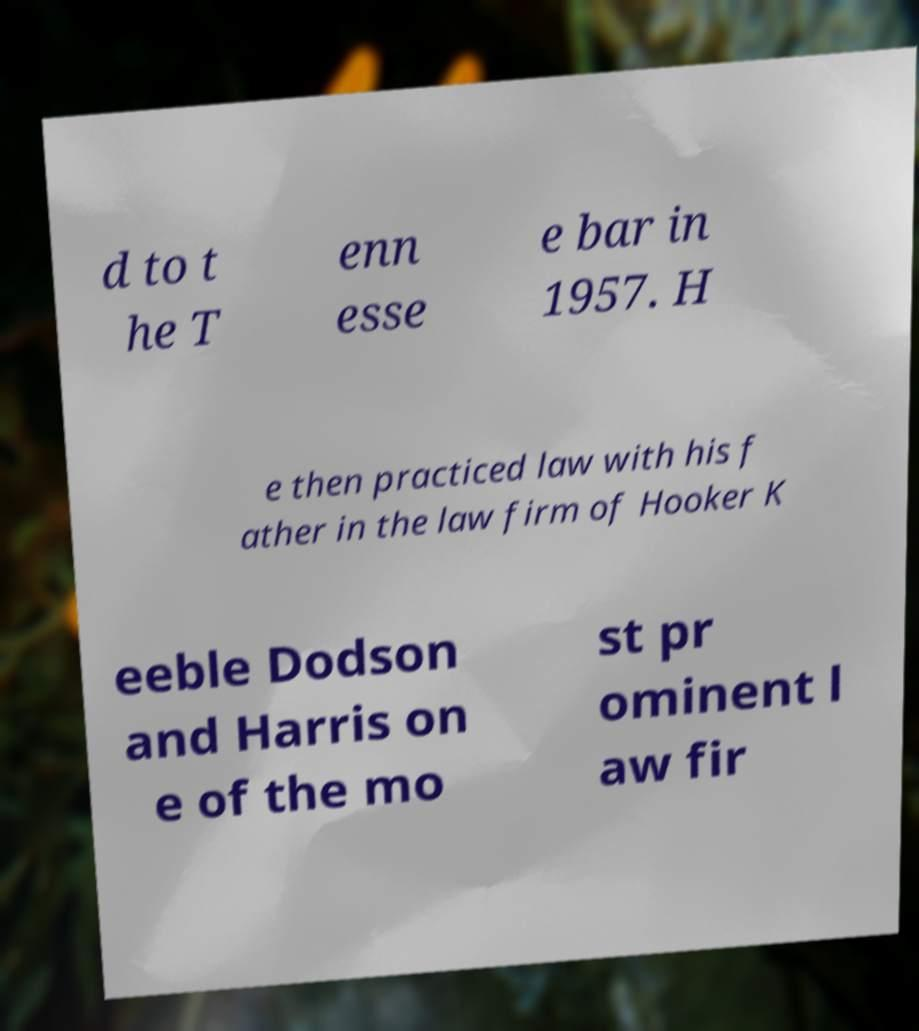What messages or text are displayed in this image? I need them in a readable, typed format. d to t he T enn esse e bar in 1957. H e then practiced law with his f ather in the law firm of Hooker K eeble Dodson and Harris on e of the mo st pr ominent l aw fir 